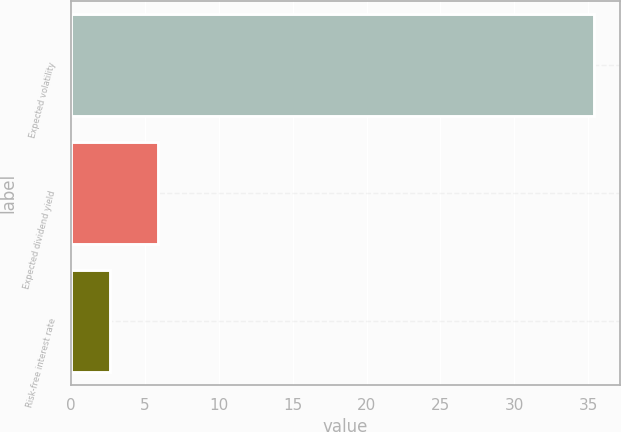Convert chart. <chart><loc_0><loc_0><loc_500><loc_500><bar_chart><fcel>Expected volatility<fcel>Expected dividend yield<fcel>Risk-free interest rate<nl><fcel>35.39<fcel>5.92<fcel>2.64<nl></chart> 